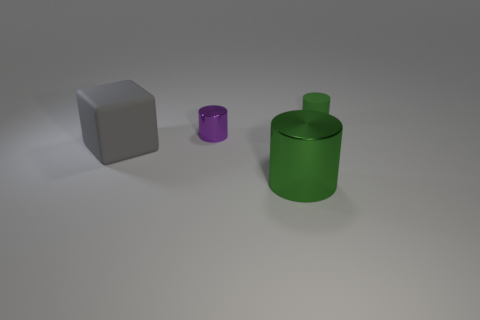There is a green cylinder that is the same size as the block; what material is it?
Your response must be concise. Metal. Do the small thing that is right of the small purple metal cylinder and the green cylinder in front of the rubber cylinder have the same material?
Your response must be concise. No. There is a thing that is the same size as the green metal cylinder; what shape is it?
Provide a short and direct response. Cube. How many other things are there of the same color as the large cylinder?
Make the answer very short. 1. There is a metal object in front of the purple object; what is its color?
Offer a very short reply. Green. What number of other objects are the same material as the large green cylinder?
Make the answer very short. 1. Is the number of tiny metallic cylinders that are left of the green matte cylinder greater than the number of large cylinders that are to the left of the green shiny object?
Your answer should be compact. Yes. There is a tiny purple thing; what number of tiny purple metallic things are behind it?
Make the answer very short. 0. Is the large gray cube made of the same material as the green cylinder that is in front of the purple metallic object?
Keep it short and to the point. No. Is there anything else that is the same shape as the large gray thing?
Offer a terse response. No. 